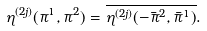<formula> <loc_0><loc_0><loc_500><loc_500>\eta ^ { ( 2 j ) } ( \pi ^ { 1 } , \pi ^ { 2 } ) = \overline { \eta ^ { ( 2 j ) } ( - \bar { \pi } ^ { 2 } , \bar { \pi } ^ { 1 } ) } .</formula> 